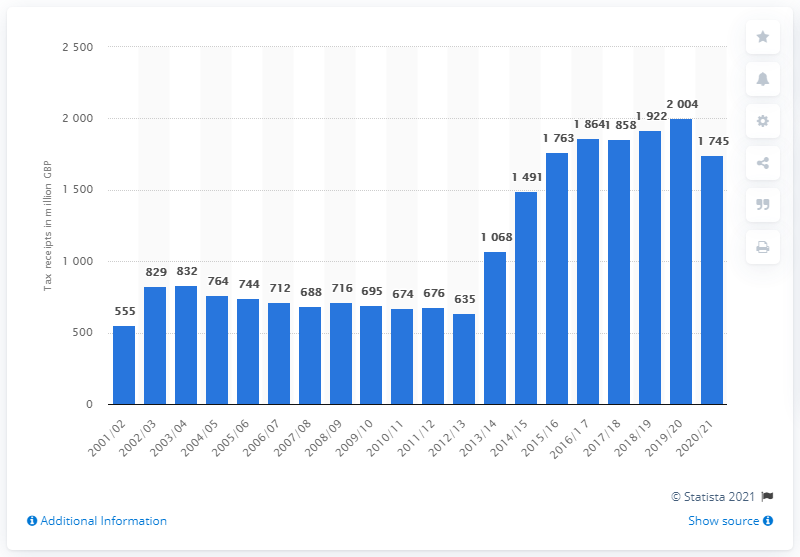Mention a couple of crucial points in this snapshot. The highest amount of receipts from the climate change levy in the last financial year was 1745. 